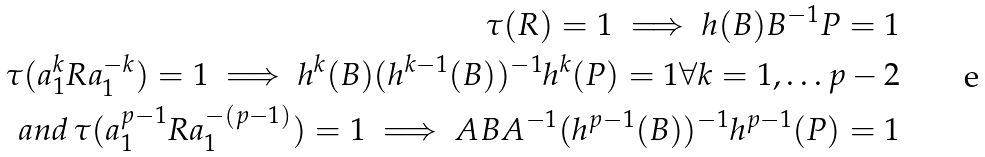<formula> <loc_0><loc_0><loc_500><loc_500>\tau ( R ) = 1 \implies h ( B ) B ^ { - 1 } P = 1 \\ \tau ( a _ { 1 } ^ { k } R a _ { 1 } ^ { - k } ) = 1 \implies h ^ { k } ( B ) ( h ^ { k - 1 } ( B ) ) ^ { - 1 } h ^ { k } ( P ) = 1 \forall k = 1 , \dots p - 2 \\ a n d \, \tau ( a _ { 1 } ^ { p - 1 } R a _ { 1 } ^ { - ( p - 1 ) } ) = 1 \implies A B A ^ { - 1 } ( h ^ { p - 1 } ( B ) ) ^ { - 1 } h ^ { p - 1 } ( P ) = 1</formula> 